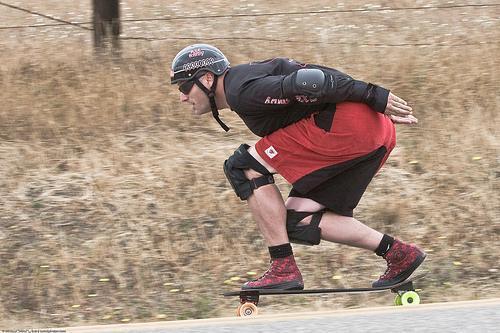How many men skateboarding?
Give a very brief answer. 1. 